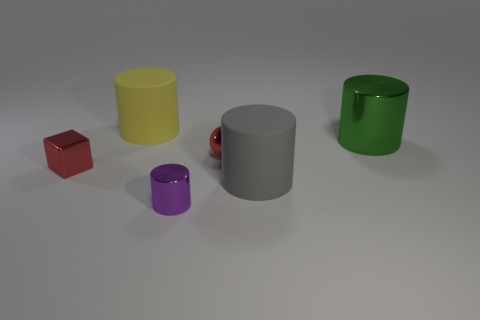Can you estimate the ratio of colorful objects to grayscale objects? In this image, there are four colorful objects (a red cube, a yellow cylinder, a purple cylinder, and a green cylinder) and two grayscale objects (a gray cylinder and what appears to be a small, reflective sphere). This results in a 2:1 ratio of colorful to grayscale objects. 